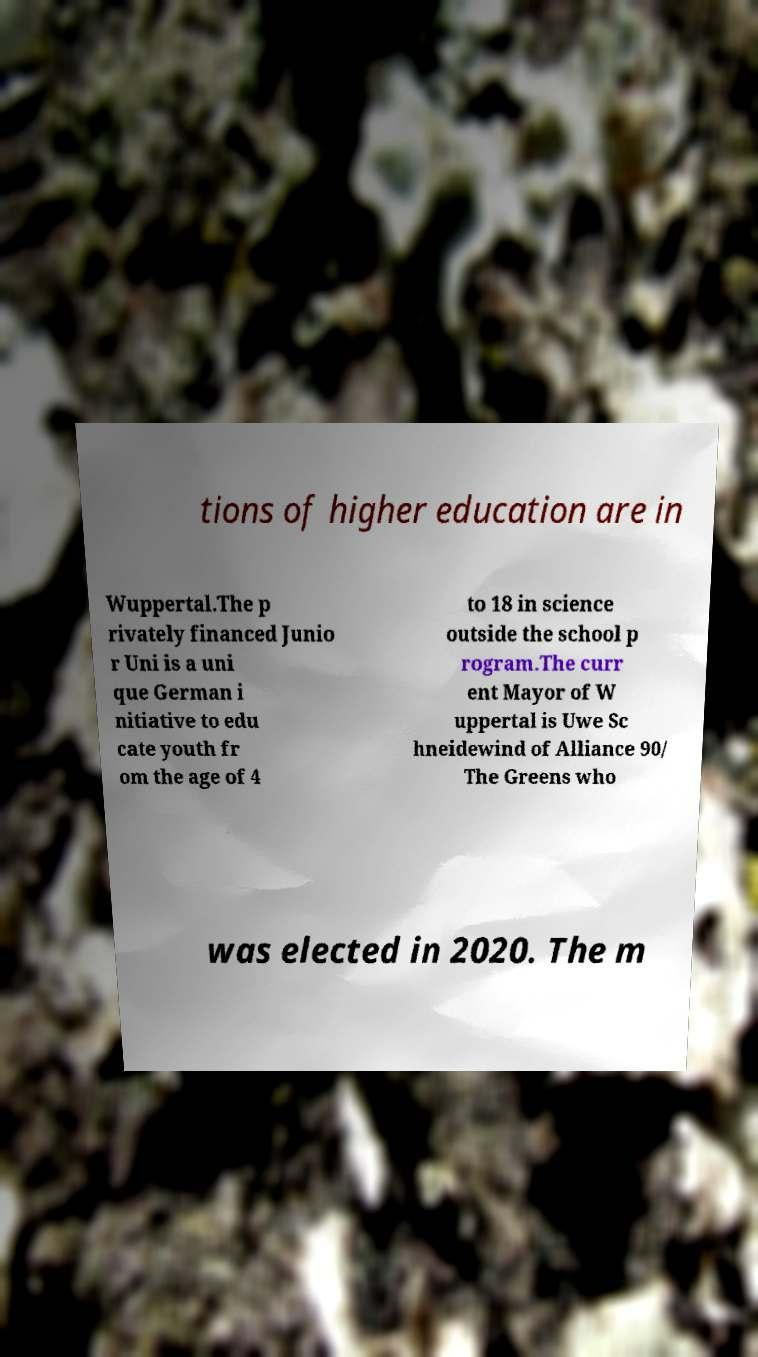Please read and relay the text visible in this image. What does it say? tions of higher education are in Wuppertal.The p rivately financed Junio r Uni is a uni que German i nitiative to edu cate youth fr om the age of 4 to 18 in science outside the school p rogram.The curr ent Mayor of W uppertal is Uwe Sc hneidewind of Alliance 90/ The Greens who was elected in 2020. The m 